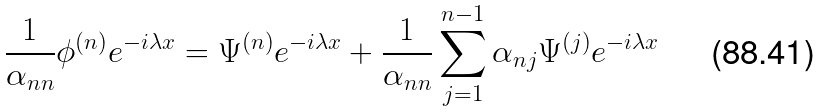Convert formula to latex. <formula><loc_0><loc_0><loc_500><loc_500>\frac { 1 } { \alpha _ { n n } } \phi ^ { ( n ) } e ^ { - i \lambda x } = \Psi ^ { ( n ) } e ^ { - i \lambda x } + \frac { 1 } { \alpha _ { n n } } \sum _ { j = 1 } ^ { n - 1 } \alpha _ { n j } \Psi ^ { ( j ) } e ^ { - i \lambda x }</formula> 